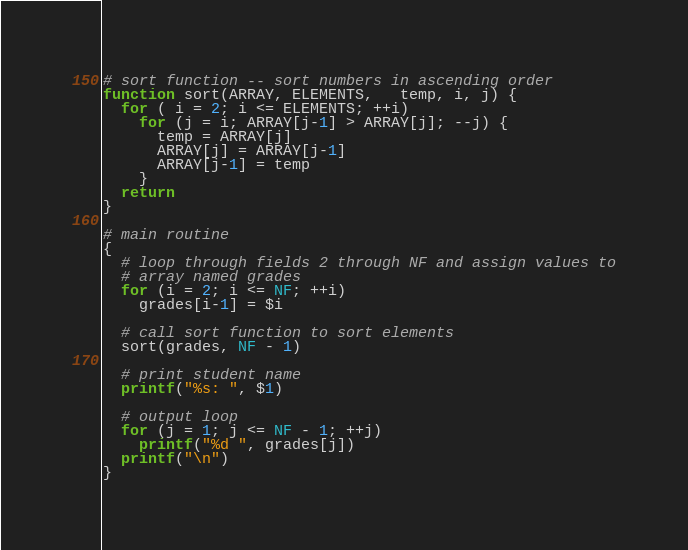Convert code to text. <code><loc_0><loc_0><loc_500><loc_500><_Awk_># sort function -- sort numbers in ascending order
function sort(ARRAY, ELEMENTS,   temp, i, j) {
  for ( i = 2; i <= ELEMENTS; ++i)
    for (j = i; ARRAY[j-1] > ARRAY[j]; --j) {
      temp = ARRAY[j]
      ARRAY[j] = ARRAY[j-1]
      ARRAY[j-1] = temp
    }
  return
}

# main routine
{
  # loop through fields 2 through NF and assign values to
  # array named grades
  for (i = 2; i <= NF; ++i)
    grades[i-1] = $i

  # call sort function to sort elements
  sort(grades, NF - 1)

  # print student name
  printf("%s: ", $1)

  # output loop
  for (j = 1; j <= NF - 1; ++j)
    printf("%d ", grades[j])
  printf("\n")
}
</code> 